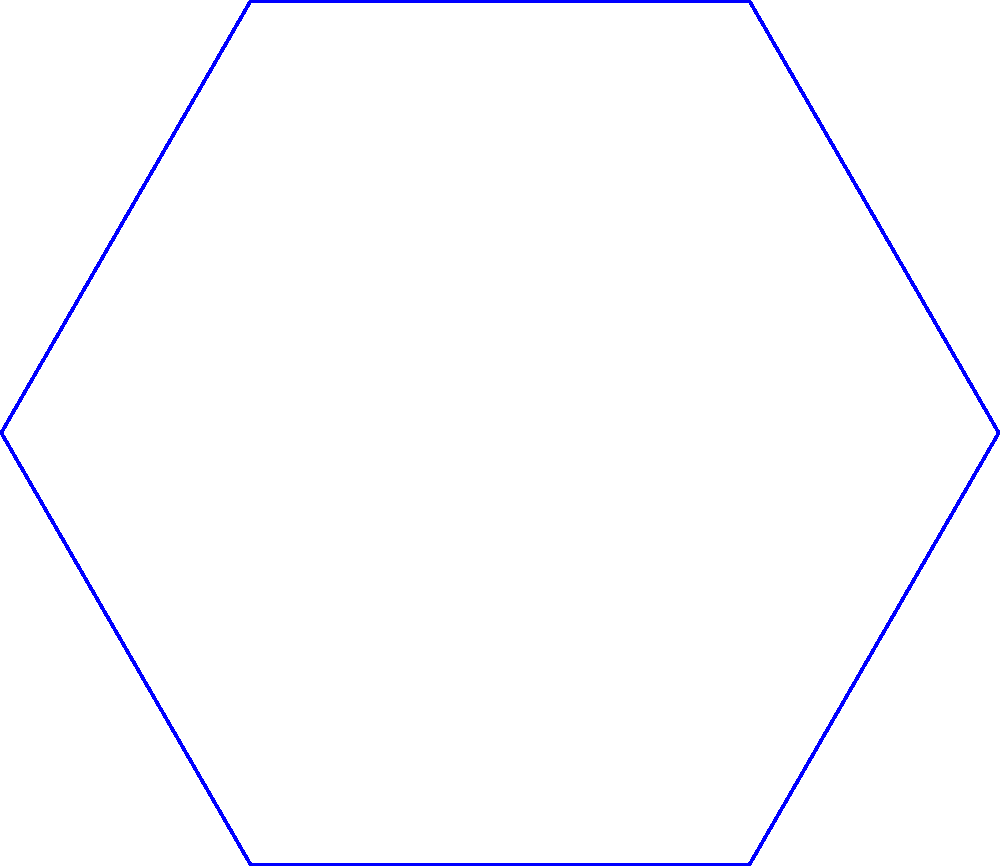During a team branding meeting, you suggest creating a new design based on transformations of the Minnesota Vikings' logo. The original logo is represented by a blue hexagon. If you reflect the logo across the line $y=x$, then rotate the original logo by 60° counterclockwise, what sequence of transformations would bring the rotated logo (green) onto the reflected logo (red)? Let's approach this step-by-step:

1) First, we need to understand the given transformations:
   - The blue hexagon is the original logo
   - The red hexagon is the result of reflecting the original across $y=x$
   - The green hexagon is the result of rotating the original by 60° counterclockwise

2) To bring the rotated logo (green) onto the reflected logo (red), we need to:
   a) Undo the 60° counterclockwise rotation
   b) Apply the reflection across $y=x$

3) Undoing the 60° counterclockwise rotation means rotating by 60° clockwise

4) So, the sequence of transformations is:
   - Rotate 60° clockwise
   - Reflect across $y=x$

5) In transformation notation, this would be written as:
   $$(reflect_{y=x}) \circ (rotate_{-60°})$$

   Where $\circ$ denotes composition of transformations, and the rightmost transformation is applied first.
Answer: Rotate 60° clockwise, then reflect across $y=x$ 